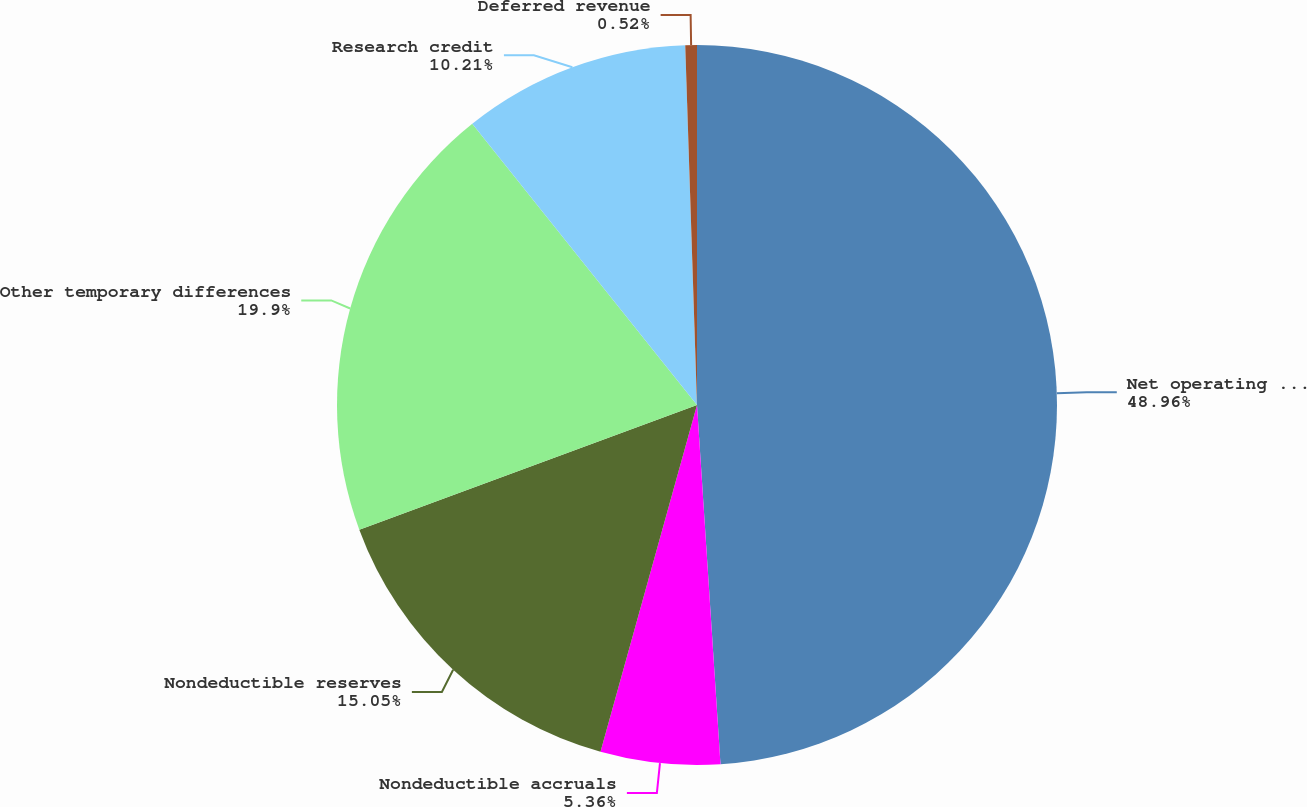Convert chart. <chart><loc_0><loc_0><loc_500><loc_500><pie_chart><fcel>Net operating loss<fcel>Nondeductible accruals<fcel>Nondeductible reserves<fcel>Other temporary differences<fcel>Research credit<fcel>Deferred revenue<nl><fcel>48.96%<fcel>5.36%<fcel>15.05%<fcel>19.9%<fcel>10.21%<fcel>0.52%<nl></chart> 